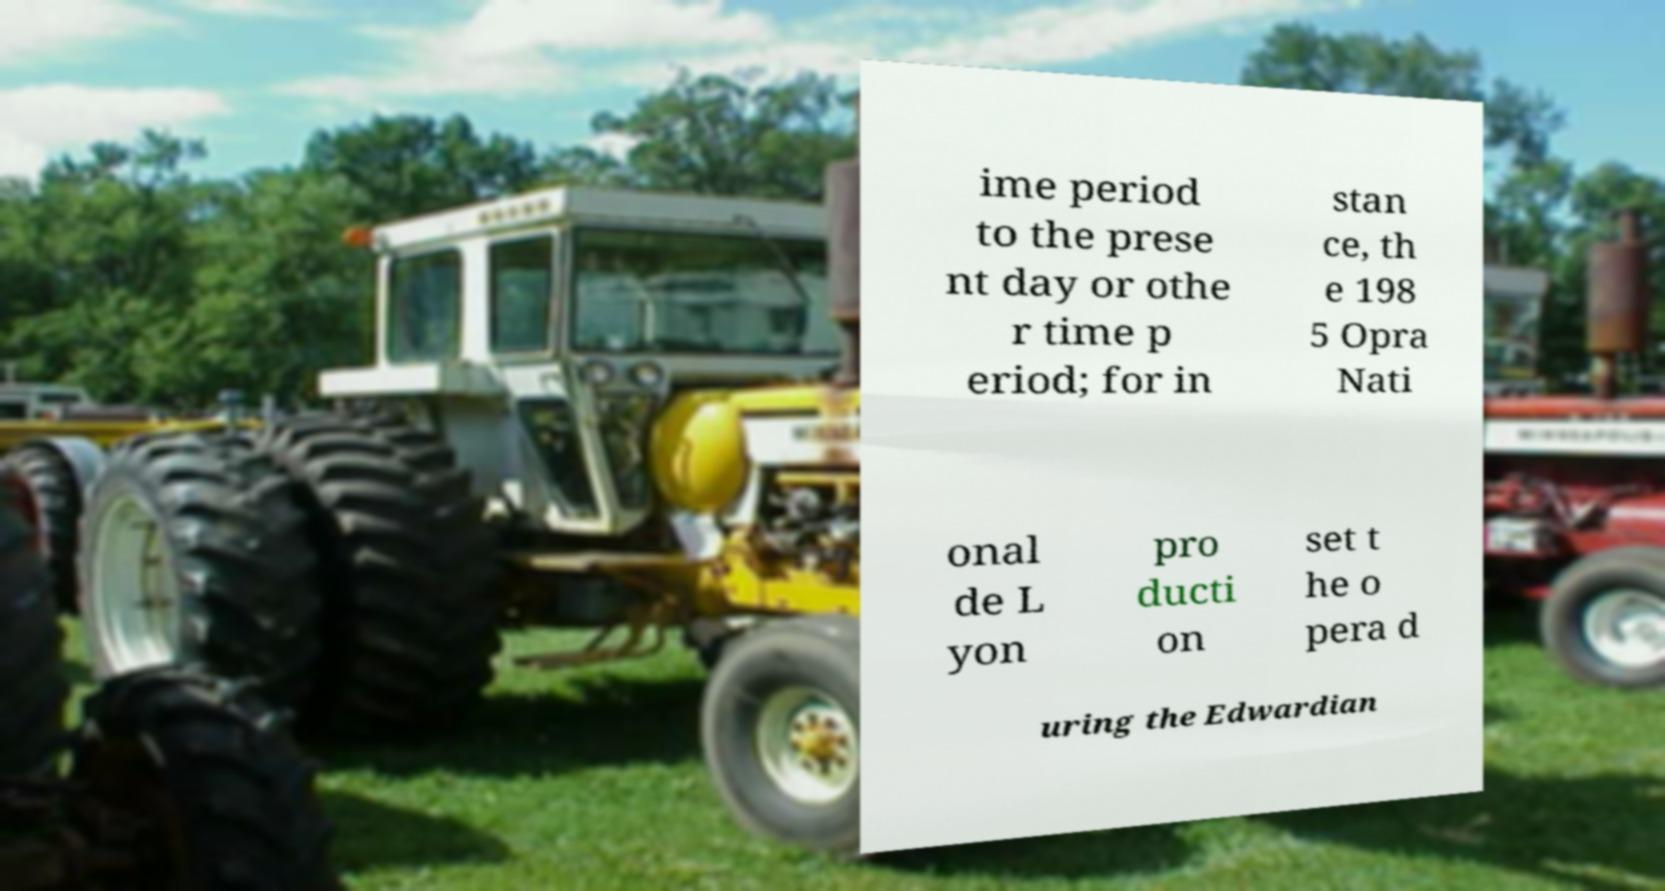I need the written content from this picture converted into text. Can you do that? ime period to the prese nt day or othe r time p eriod; for in stan ce, th e 198 5 Opra Nati onal de L yon pro ducti on set t he o pera d uring the Edwardian 